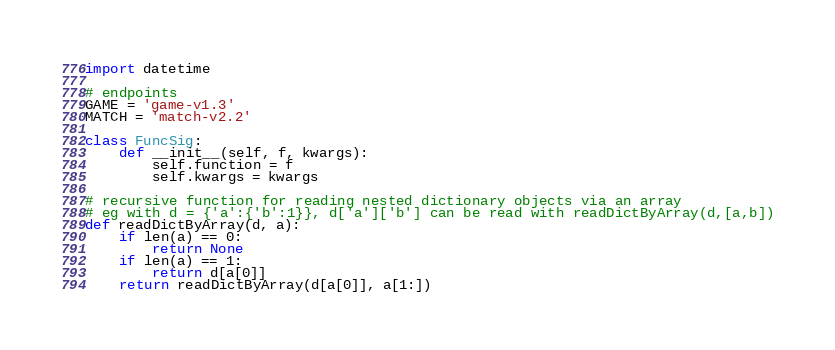Convert code to text. <code><loc_0><loc_0><loc_500><loc_500><_Python_>import datetime

# endpoints
GAME = 'game-v1.3'
MATCH = 'match-v2.2'

class FuncSig:
    def __init__(self, f, kwargs):
        self.function = f
        self.kwargs = kwargs

# recursive function for reading nested dictionary objects via an array
# eg with d = {'a':{'b':1}}, d['a']['b'] can be read with readDictByArray(d,[a,b])
def readDictByArray(d, a):
    if len(a) == 0:
        return None
    if len(a) == 1:
        return d[a[0]]
    return readDictByArray(d[a[0]], a[1:])

</code> 